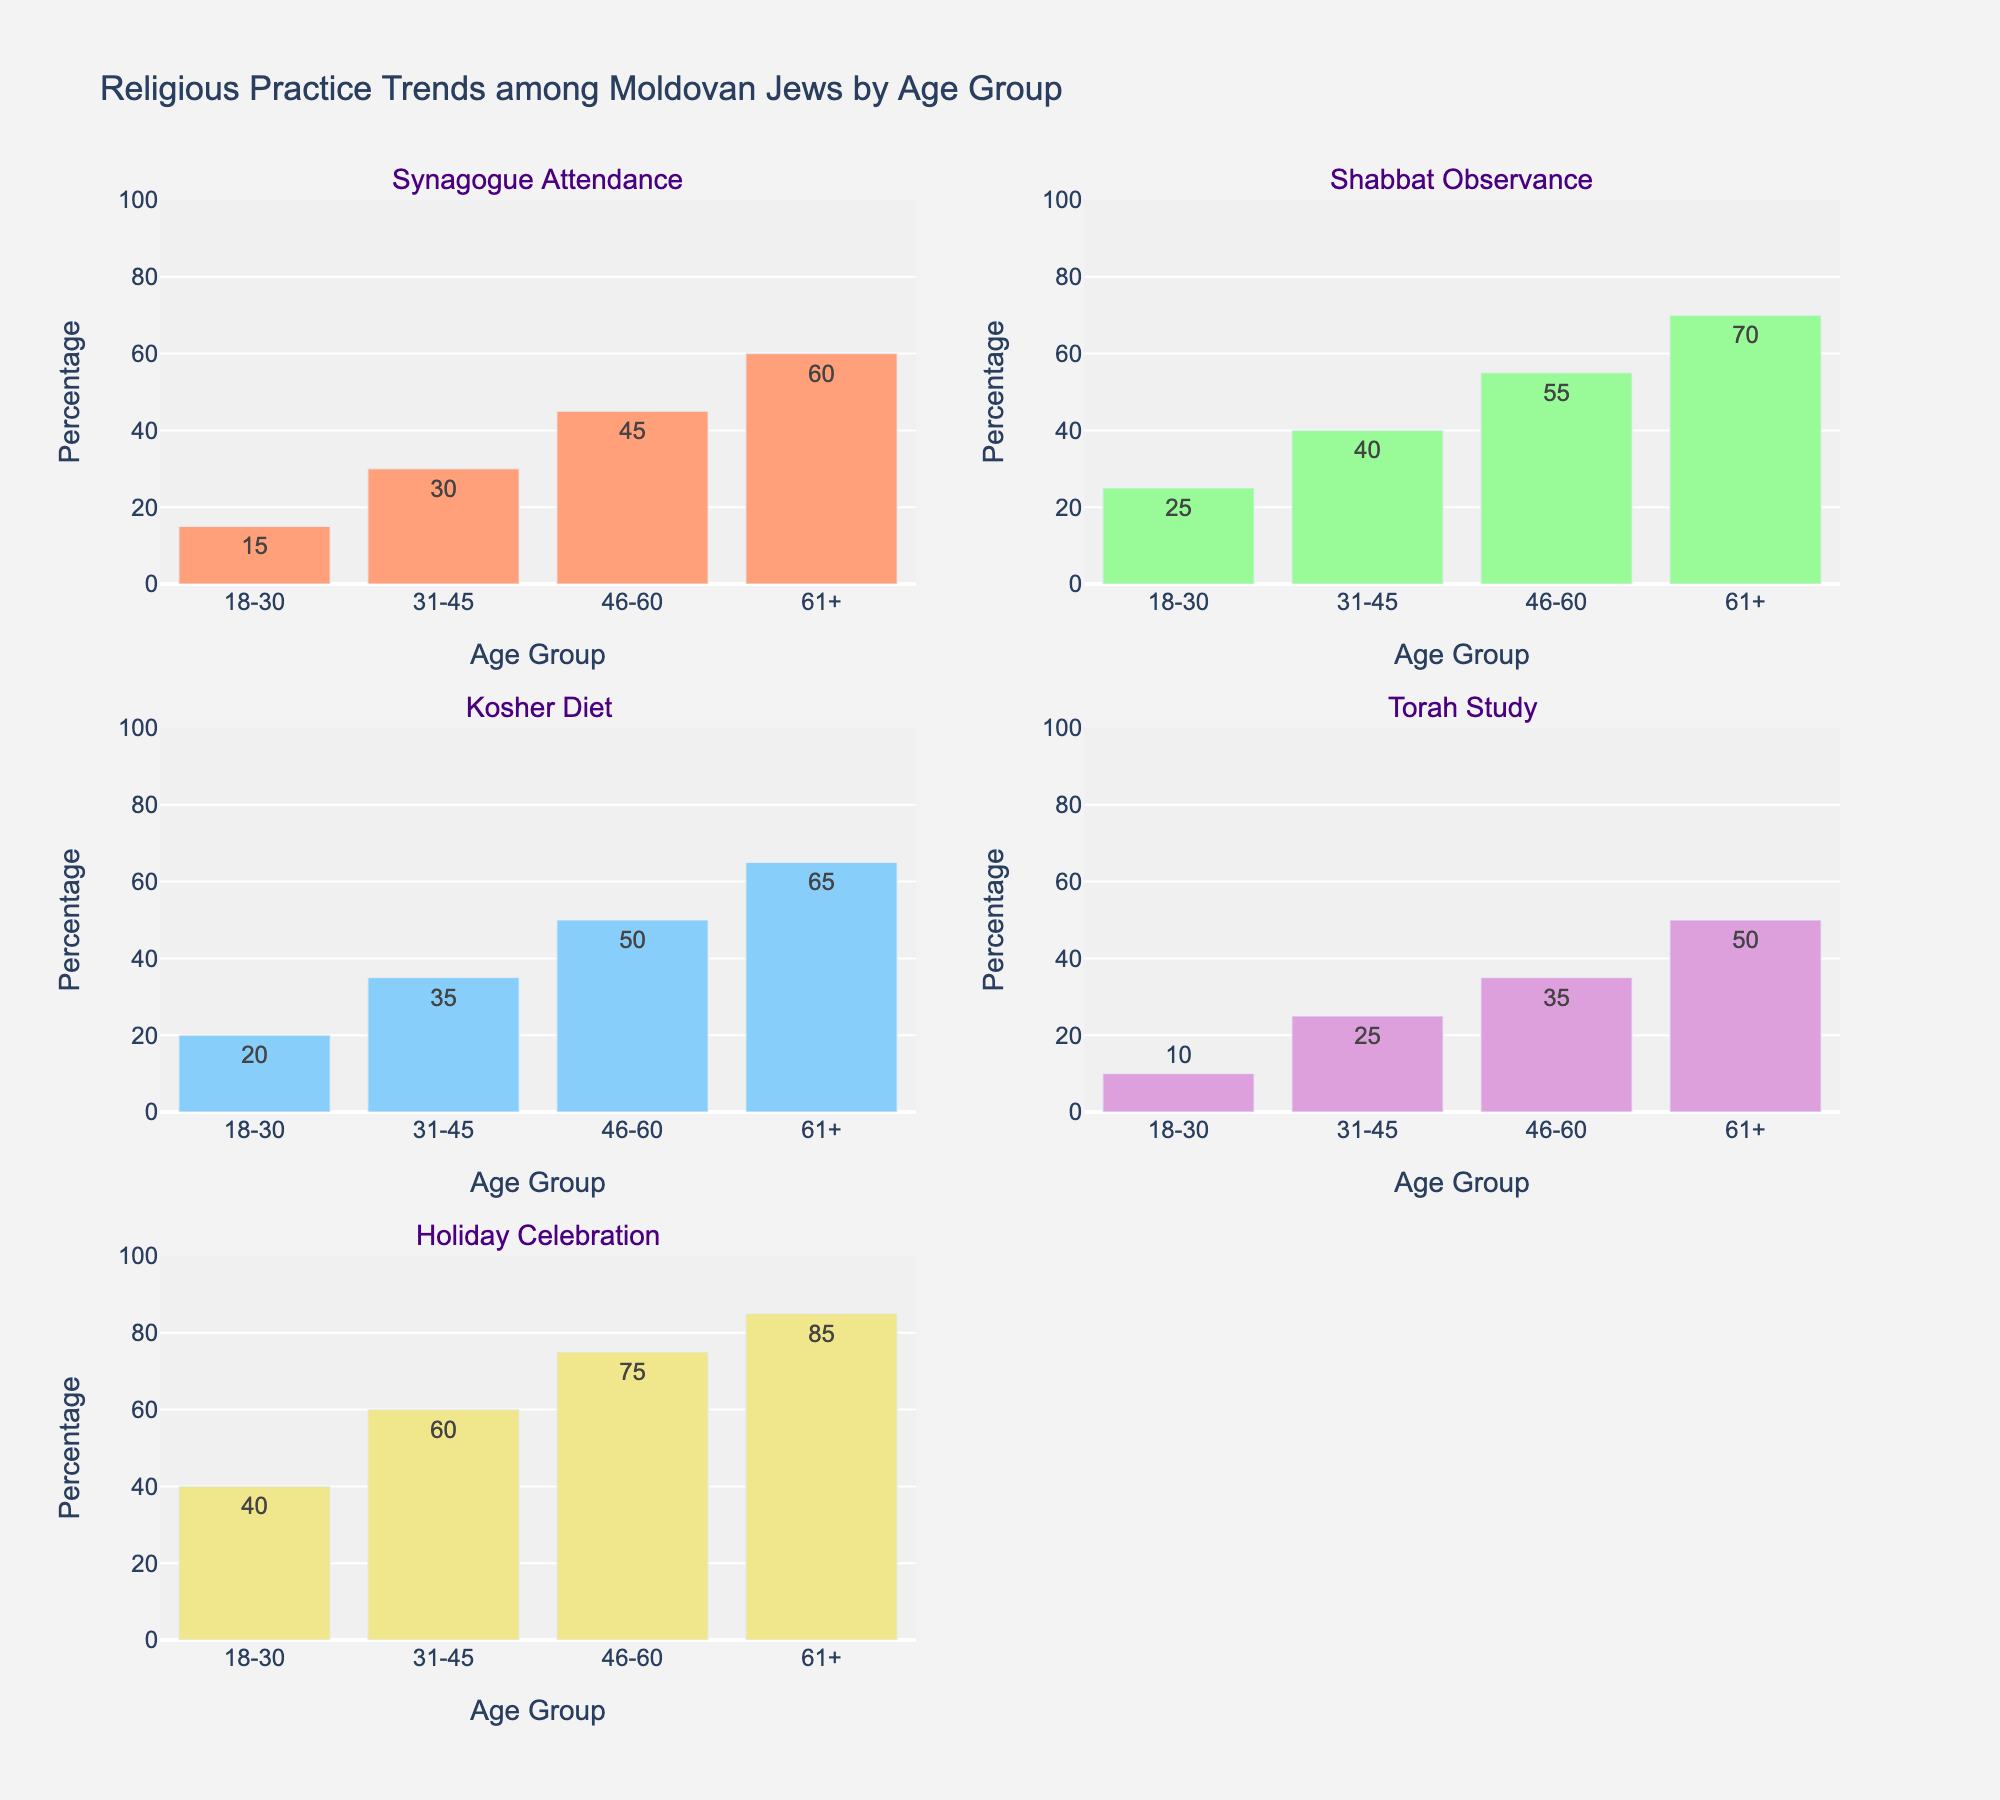What's the title of the figure? The title is displayed at the top center of the figure, typically in larger and bold font. It provides a summary of the information presented in the figure.
Answer: Religious Practice Trends among Moldovan Jews by Age Group What are the different religious practices shown in the figure? Each subplot within the figure is titled with a different religious practice, representing the different categories plotted.
Answer: Synagogue Attendance, Shabbat Observance, Kosher Diet, Torah Study, Holiday Celebration Which age group has the highest percentage of synagogue attendance? The subplot for synagogue attendance shows bars for each age group. The bar with the highest value indicates the age group with the highest percentage.
Answer: 61+ What is the difference in holiday celebration percentages between the age groups 46-60 and 61+? Examine the bars for the Holiday Celebration subplot corresponding to age groups 46-60 and 61+. Subtract the value for 46-60 from the value for 61+.
Answer: 10 How does Shabbat observance change with age? Look at the Shabbat Observance subplot and compare the heights of the bars across different age groups to identify the trend.
Answer: Increases with age Which religious practice shows the lowest percentage for the age group 18-30? For the age group 18-30, compare the heights of bars across all subplots to find the lowest value.
Answer: Torah Study Compare the percentages of the kosher diet for the age groups 31-45 and 61+. Refer to the Kosher Diet subplot and compare the heights of the bars for the age groups 31-45 and 61+.
Answer: 31-45: 35, 61+: 65 What is the average percentage of Torah study across all age groups? Sum the percentages of Torah Study for all age groups and divide by the number of age groups.
Answer: (10 + 25 + 35 + 50) / 4 = 30 Which age group shows the most consistent increase in all religious practices? Analyze each subplot and check the age group that consistently shows an increasing trend across all religious practices.
Answer: 61+ In the age group 31-45, which religious practice has the highest percentage? Look at all subplots and identify which bar corresponding to the age group 31-45 is the highest.
Answer: Holiday Celebration 